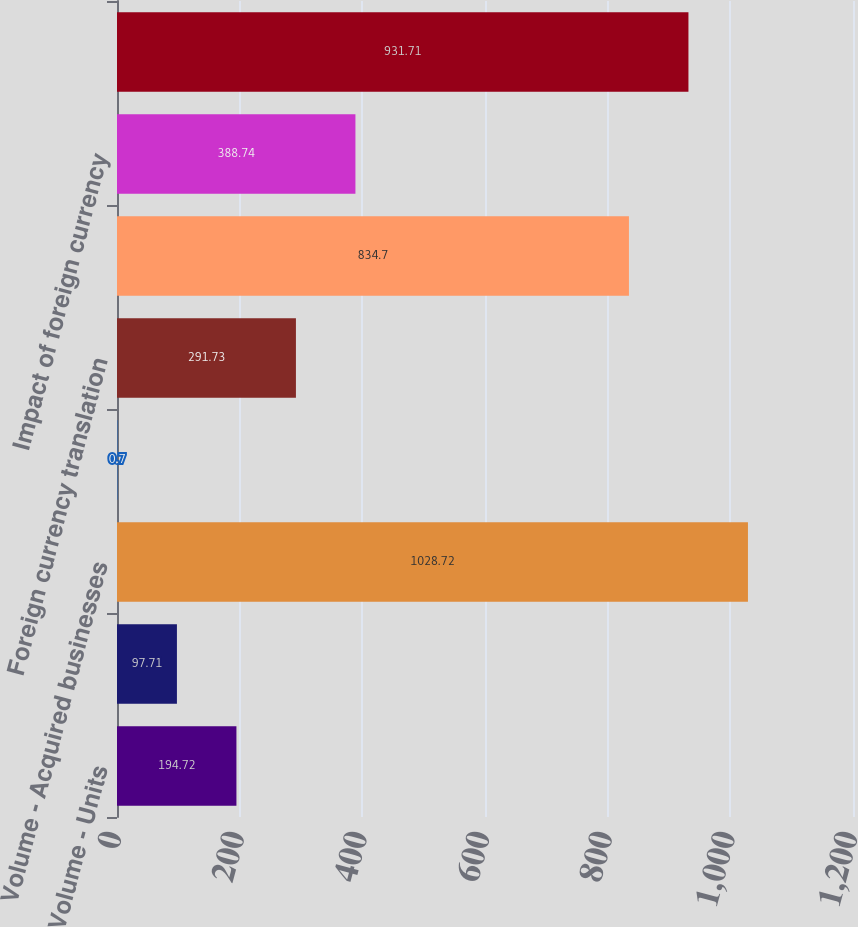Convert chart. <chart><loc_0><loc_0><loc_500><loc_500><bar_chart><fcel>Volume - Units<fcel>change<fcel>Volume - Acquired businesses<fcel>Product price/mix<fcel>Foreign currency translation<fcel>Total<fcel>Impact of foreign currency<fcel>Total constant dollar change<nl><fcel>194.72<fcel>97.71<fcel>1028.72<fcel>0.7<fcel>291.73<fcel>834.7<fcel>388.74<fcel>931.71<nl></chart> 